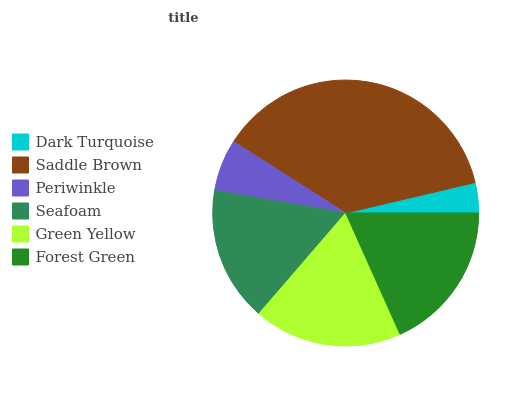Is Dark Turquoise the minimum?
Answer yes or no. Yes. Is Saddle Brown the maximum?
Answer yes or no. Yes. Is Periwinkle the minimum?
Answer yes or no. No. Is Periwinkle the maximum?
Answer yes or no. No. Is Saddle Brown greater than Periwinkle?
Answer yes or no. Yes. Is Periwinkle less than Saddle Brown?
Answer yes or no. Yes. Is Periwinkle greater than Saddle Brown?
Answer yes or no. No. Is Saddle Brown less than Periwinkle?
Answer yes or no. No. Is Green Yellow the high median?
Answer yes or no. Yes. Is Seafoam the low median?
Answer yes or no. Yes. Is Forest Green the high median?
Answer yes or no. No. Is Periwinkle the low median?
Answer yes or no. No. 